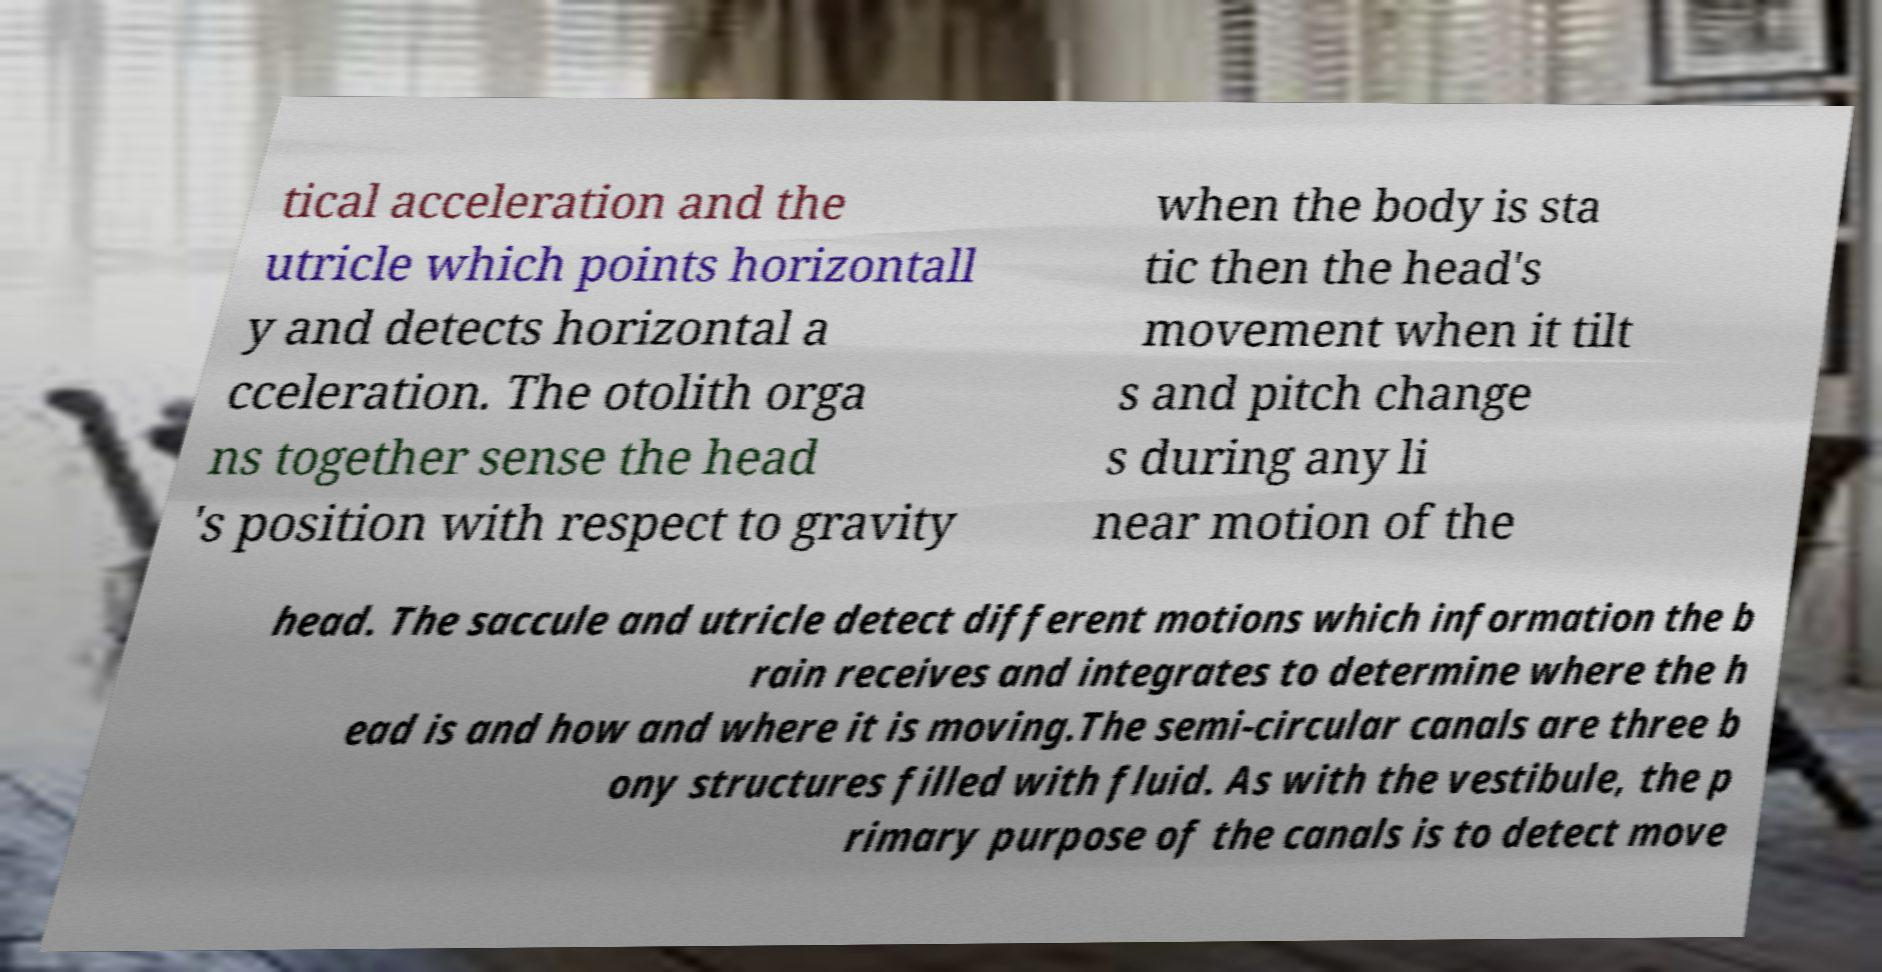What messages or text are displayed in this image? I need them in a readable, typed format. tical acceleration and the utricle which points horizontall y and detects horizontal a cceleration. The otolith orga ns together sense the head 's position with respect to gravity when the body is sta tic then the head's movement when it tilt s and pitch change s during any li near motion of the head. The saccule and utricle detect different motions which information the b rain receives and integrates to determine where the h ead is and how and where it is moving.The semi-circular canals are three b ony structures filled with fluid. As with the vestibule, the p rimary purpose of the canals is to detect move 